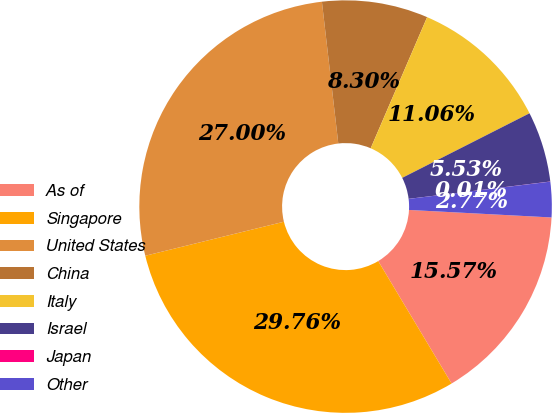Convert chart to OTSL. <chart><loc_0><loc_0><loc_500><loc_500><pie_chart><fcel>As of<fcel>Singapore<fcel>United States<fcel>China<fcel>Italy<fcel>Israel<fcel>Japan<fcel>Other<nl><fcel>15.57%<fcel>29.76%<fcel>27.0%<fcel>8.3%<fcel>11.06%<fcel>5.53%<fcel>0.01%<fcel>2.77%<nl></chart> 